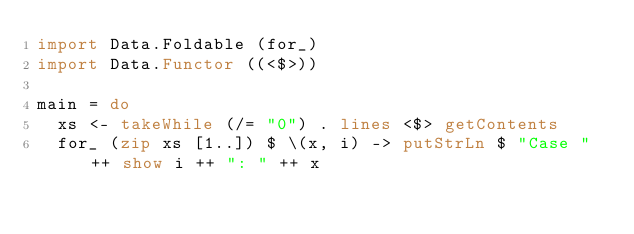<code> <loc_0><loc_0><loc_500><loc_500><_Haskell_>import Data.Foldable (for_)
import Data.Functor ((<$>))

main = do
  xs <- takeWhile (/= "0") . lines <$> getContents
  for_ (zip xs [1..]) $ \(x, i) -> putStrLn $ "Case " ++ show i ++ ": " ++ x

</code> 